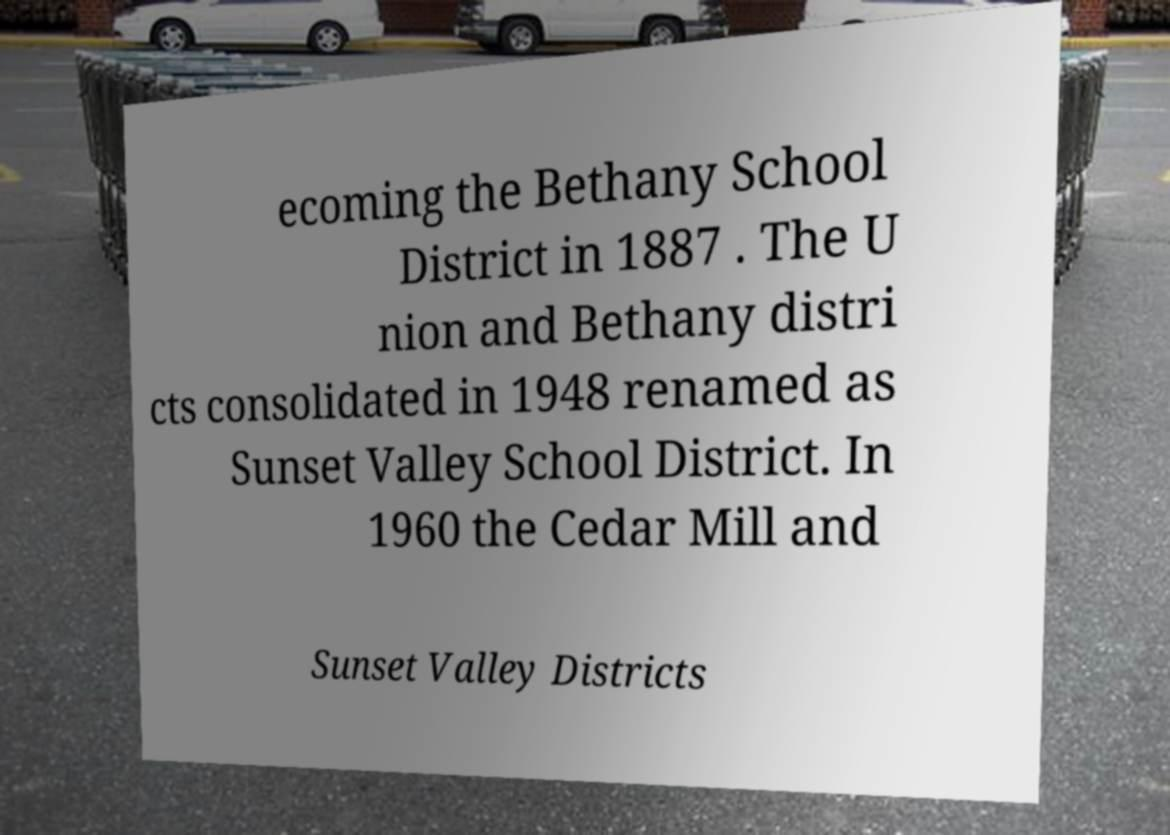For documentation purposes, I need the text within this image transcribed. Could you provide that? ecoming the Bethany School District in 1887 . The U nion and Bethany distri cts consolidated in 1948 renamed as Sunset Valley School District. In 1960 the Cedar Mill and Sunset Valley Districts 